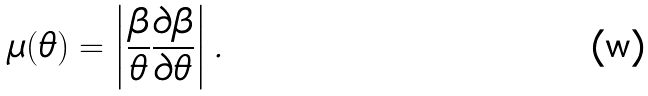Convert formula to latex. <formula><loc_0><loc_0><loc_500><loc_500>\mu ( \theta ) = \left | \frac { \beta } { \theta } \frac { \partial \beta } { \partial \theta } \right | .</formula> 